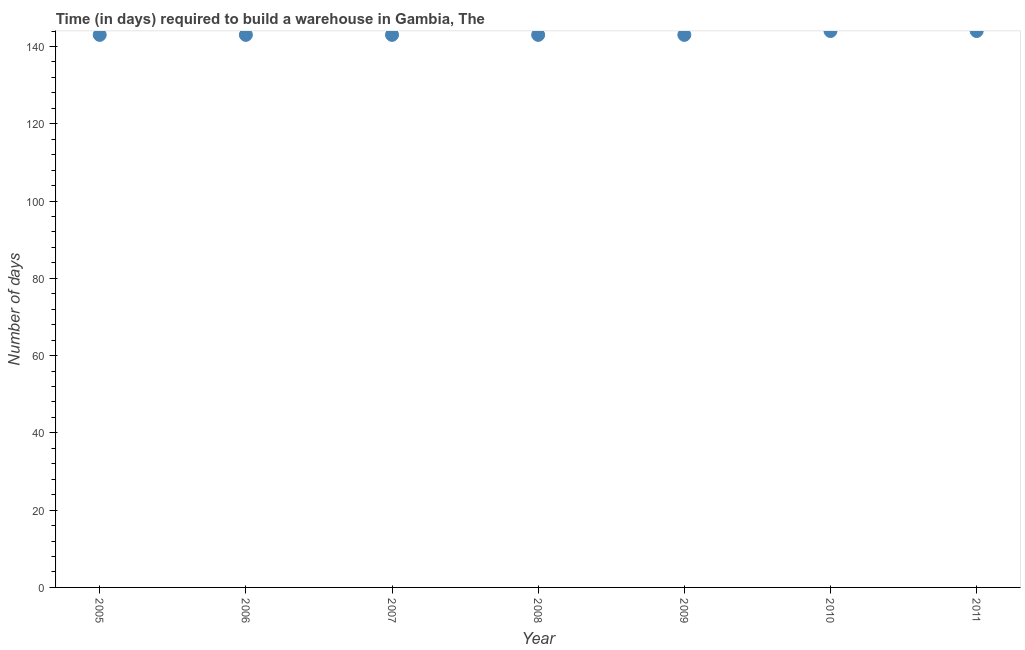What is the time required to build a warehouse in 2010?
Make the answer very short. 144. Across all years, what is the maximum time required to build a warehouse?
Your answer should be compact. 144. Across all years, what is the minimum time required to build a warehouse?
Provide a short and direct response. 143. In which year was the time required to build a warehouse maximum?
Provide a succinct answer. 2010. In which year was the time required to build a warehouse minimum?
Your response must be concise. 2005. What is the sum of the time required to build a warehouse?
Provide a succinct answer. 1003. What is the difference between the time required to build a warehouse in 2008 and 2011?
Ensure brevity in your answer.  -1. What is the average time required to build a warehouse per year?
Your answer should be very brief. 143.29. What is the median time required to build a warehouse?
Your answer should be compact. 143. Do a majority of the years between 2011 and 2010 (inclusive) have time required to build a warehouse greater than 80 days?
Provide a succinct answer. No. What is the ratio of the time required to build a warehouse in 2006 to that in 2011?
Keep it short and to the point. 0.99. Is the difference between the time required to build a warehouse in 2005 and 2008 greater than the difference between any two years?
Make the answer very short. No. Is the sum of the time required to build a warehouse in 2009 and 2011 greater than the maximum time required to build a warehouse across all years?
Your answer should be compact. Yes. What is the difference between the highest and the lowest time required to build a warehouse?
Provide a short and direct response. 1. In how many years, is the time required to build a warehouse greater than the average time required to build a warehouse taken over all years?
Your answer should be compact. 2. Does the time required to build a warehouse monotonically increase over the years?
Provide a short and direct response. No. How many dotlines are there?
Your answer should be very brief. 1. How many years are there in the graph?
Provide a short and direct response. 7. What is the difference between two consecutive major ticks on the Y-axis?
Provide a short and direct response. 20. Are the values on the major ticks of Y-axis written in scientific E-notation?
Keep it short and to the point. No. Does the graph contain any zero values?
Give a very brief answer. No. What is the title of the graph?
Provide a short and direct response. Time (in days) required to build a warehouse in Gambia, The. What is the label or title of the Y-axis?
Your answer should be compact. Number of days. What is the Number of days in 2005?
Offer a very short reply. 143. What is the Number of days in 2006?
Provide a short and direct response. 143. What is the Number of days in 2007?
Offer a very short reply. 143. What is the Number of days in 2008?
Ensure brevity in your answer.  143. What is the Number of days in 2009?
Your answer should be compact. 143. What is the Number of days in 2010?
Provide a short and direct response. 144. What is the Number of days in 2011?
Offer a very short reply. 144. What is the difference between the Number of days in 2005 and 2006?
Your answer should be compact. 0. What is the difference between the Number of days in 2005 and 2008?
Your answer should be compact. 0. What is the difference between the Number of days in 2005 and 2009?
Give a very brief answer. 0. What is the difference between the Number of days in 2005 and 2011?
Keep it short and to the point. -1. What is the difference between the Number of days in 2006 and 2007?
Give a very brief answer. 0. What is the difference between the Number of days in 2006 and 2009?
Keep it short and to the point. 0. What is the difference between the Number of days in 2006 and 2010?
Your answer should be compact. -1. What is the difference between the Number of days in 2007 and 2009?
Make the answer very short. 0. What is the difference between the Number of days in 2007 and 2011?
Offer a very short reply. -1. What is the difference between the Number of days in 2008 and 2009?
Offer a very short reply. 0. What is the difference between the Number of days in 2009 and 2010?
Offer a terse response. -1. What is the difference between the Number of days in 2009 and 2011?
Give a very brief answer. -1. What is the difference between the Number of days in 2010 and 2011?
Your answer should be compact. 0. What is the ratio of the Number of days in 2005 to that in 2006?
Offer a very short reply. 1. What is the ratio of the Number of days in 2005 to that in 2007?
Ensure brevity in your answer.  1. What is the ratio of the Number of days in 2005 to that in 2009?
Provide a short and direct response. 1. What is the ratio of the Number of days in 2005 to that in 2010?
Provide a succinct answer. 0.99. What is the ratio of the Number of days in 2005 to that in 2011?
Provide a short and direct response. 0.99. What is the ratio of the Number of days in 2006 to that in 2007?
Make the answer very short. 1. What is the ratio of the Number of days in 2006 to that in 2008?
Give a very brief answer. 1. What is the ratio of the Number of days in 2006 to that in 2009?
Give a very brief answer. 1. What is the ratio of the Number of days in 2006 to that in 2011?
Your answer should be compact. 0.99. What is the ratio of the Number of days in 2007 to that in 2009?
Your response must be concise. 1. What is the ratio of the Number of days in 2007 to that in 2010?
Provide a short and direct response. 0.99. What is the ratio of the Number of days in 2007 to that in 2011?
Ensure brevity in your answer.  0.99. What is the ratio of the Number of days in 2008 to that in 2009?
Ensure brevity in your answer.  1. What is the ratio of the Number of days in 2009 to that in 2010?
Provide a succinct answer. 0.99. What is the ratio of the Number of days in 2009 to that in 2011?
Your answer should be compact. 0.99. 